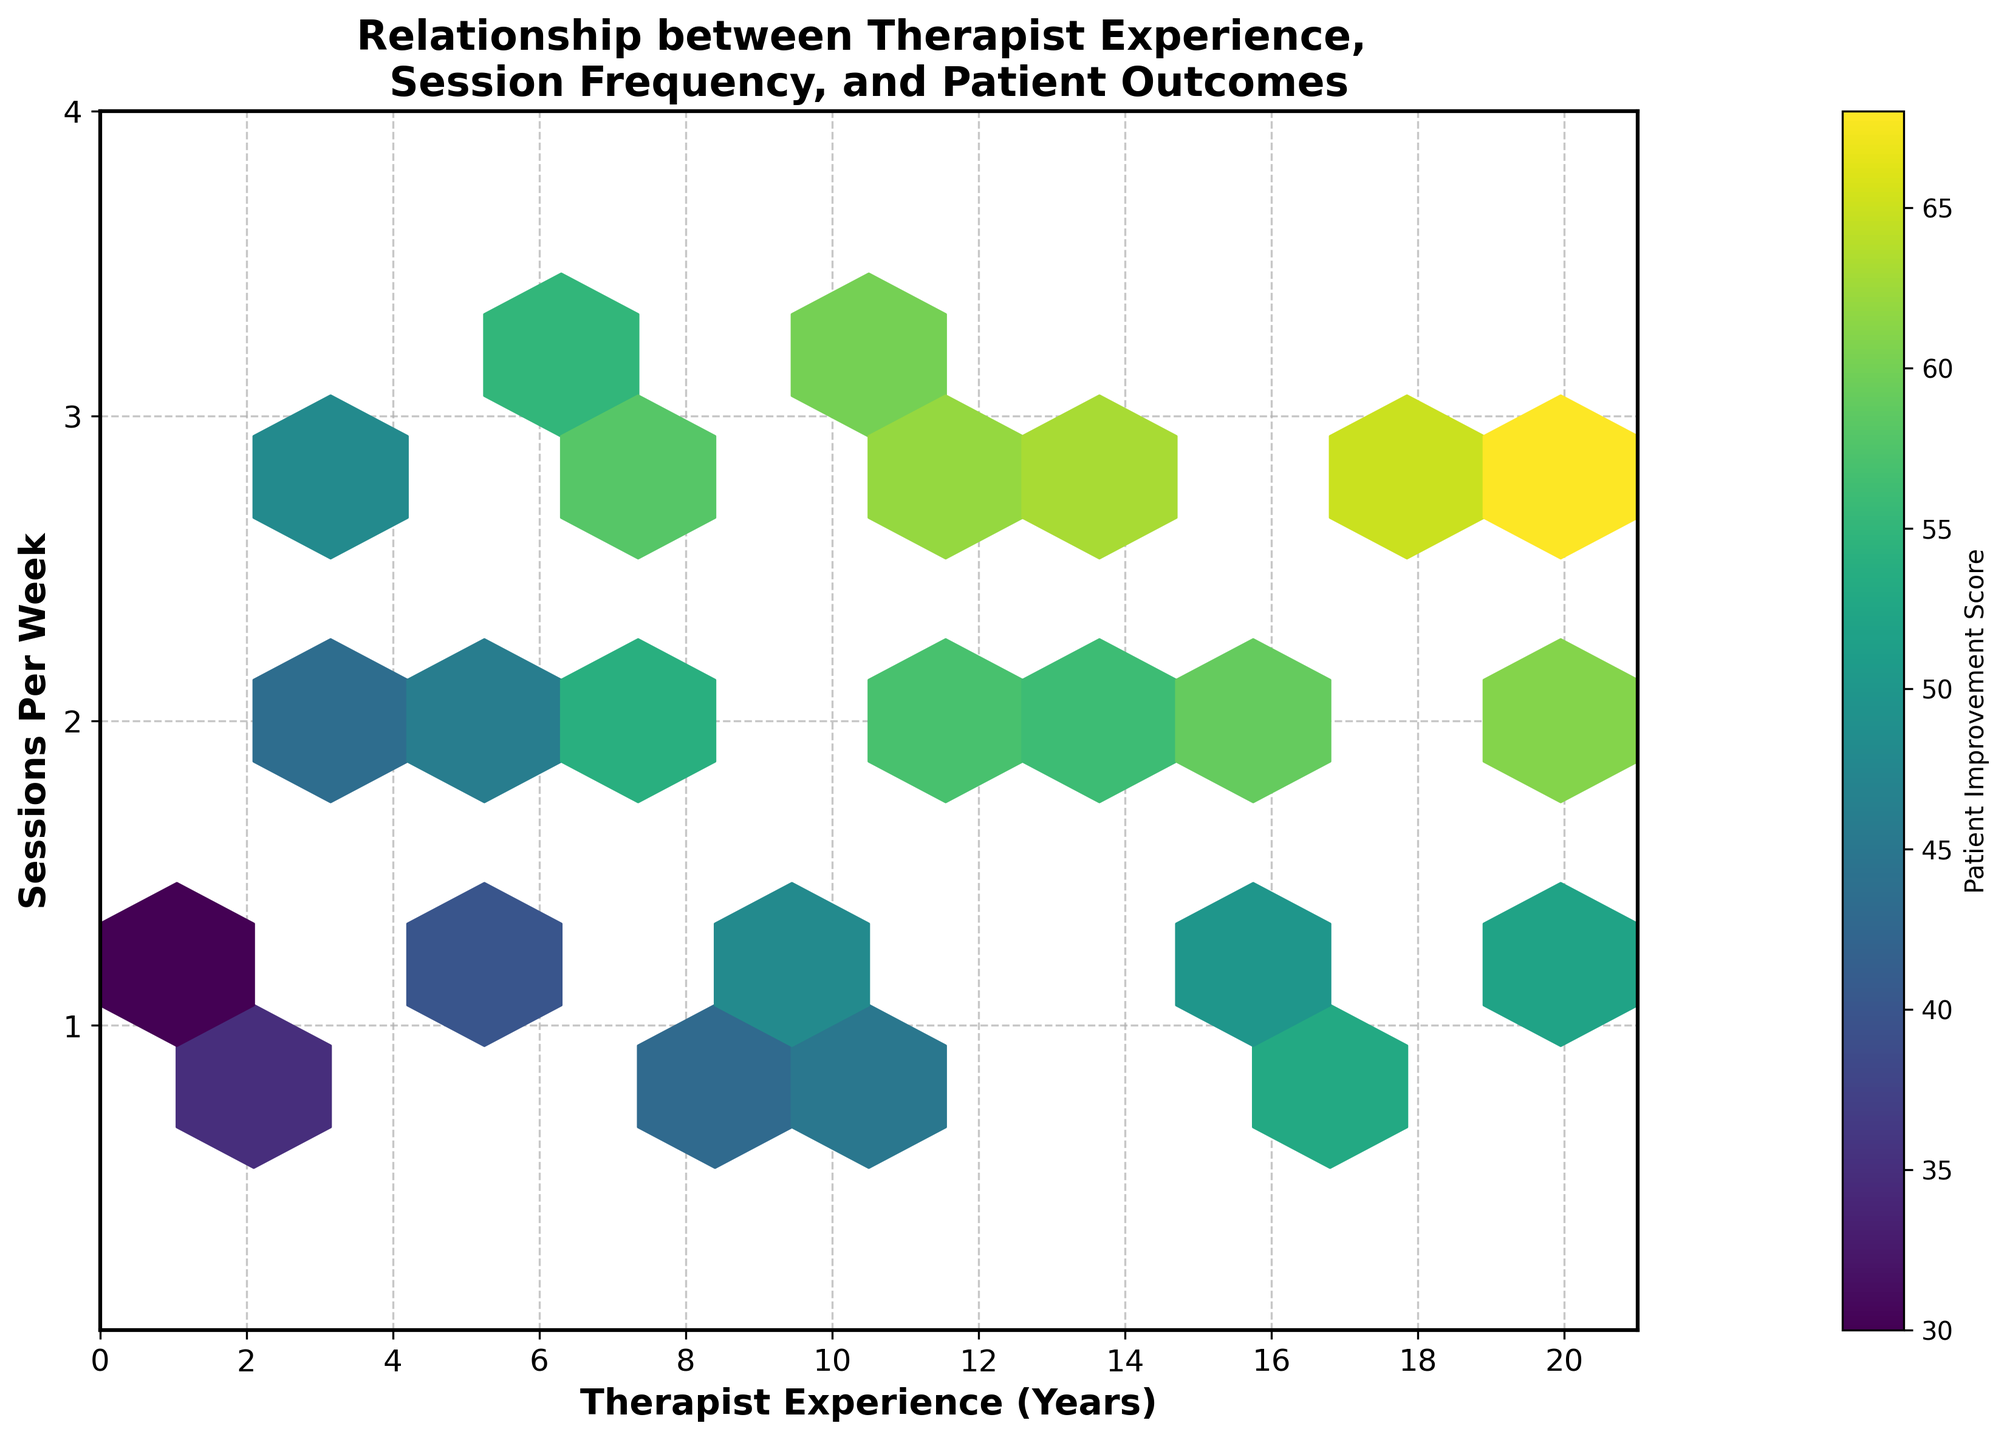What is the title of the figure? The title of the figure is at the top center of the plot. Reading the text directly gives us the title.
Answer: Relationship between Therapist Experience, Session Frequency, and Patient Outcomes What does the color represent in this hexbin plot? In a hexbin plot, the color indicates the aggregated value of the data points in each hexagon. The color bar gives a range to interpret these values.
Answer: Patient Improvement Score How many bins are there along the x-axis? Count the number of divisions along the x-axis between 0 and 21.
Answer: 10 Which therapist experience level has the highest patient improvement score? Find the experience level linked with the darkest hexagon which represents the highest score. The color of the hexagon matches the highest value on the color bar.
Answer: 20 years What is the range for the therapist experience on the x-axis? Look at the minimum and maximum values along the x-axis to determine the range.
Answer: 0 to 21 years How does session frequency affect patient improvement scores for therapists with 10 years of experience? Examine the hexagons for 10 years of therapist experience; observe the colors for different session frequencies to infer the effect on patient scores.
Answer: Higher session frequency correlates with higher improvement scores Do therapists with more experience always have higher patient improvement scores? Check the color trends for hexagons as you move along the x-axis from lower to higher experience levels, irrespective of session frequency.
Answer: No Which has a greater impact on patient improvement score, therapist experience, or session frequency? Compare the patterns of colors across different experience levels and session frequencies to identify the stronger determining factor.
Answer: Session frequency What trend can be inferred about improvements with 3 sessions per week? Evaluate hexagons specifically for the y-axis value of 3, noting the colors associated with different experience levels.
Answer: Generally higher improvement scores What is the average patient improvement score for therapists with 5 years of experience? Look at the hexagons around 5 years; average the scores as indicated by the colors linked with different session frequencies. This requires visual estimation.
Answer: Around 43 